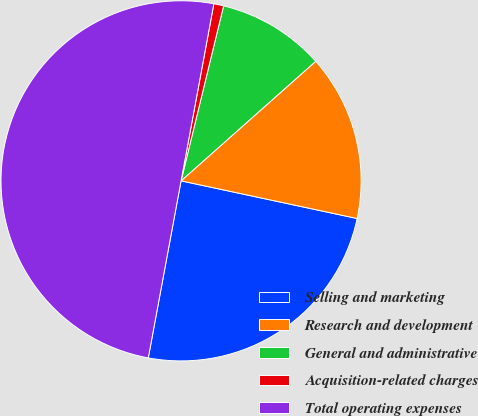<chart> <loc_0><loc_0><loc_500><loc_500><pie_chart><fcel>Selling and marketing<fcel>Research and development<fcel>General and administrative<fcel>Acquisition-related charges<fcel>Total operating expenses<nl><fcel>24.56%<fcel>14.91%<fcel>9.65%<fcel>0.88%<fcel>50.0%<nl></chart> 